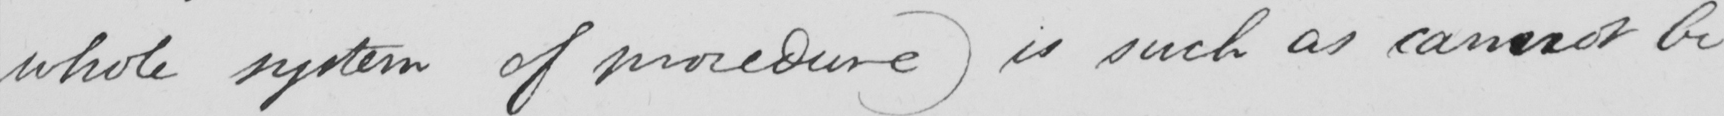Please transcribe the handwritten text in this image. whole system of procedure )  is such as cannot be 